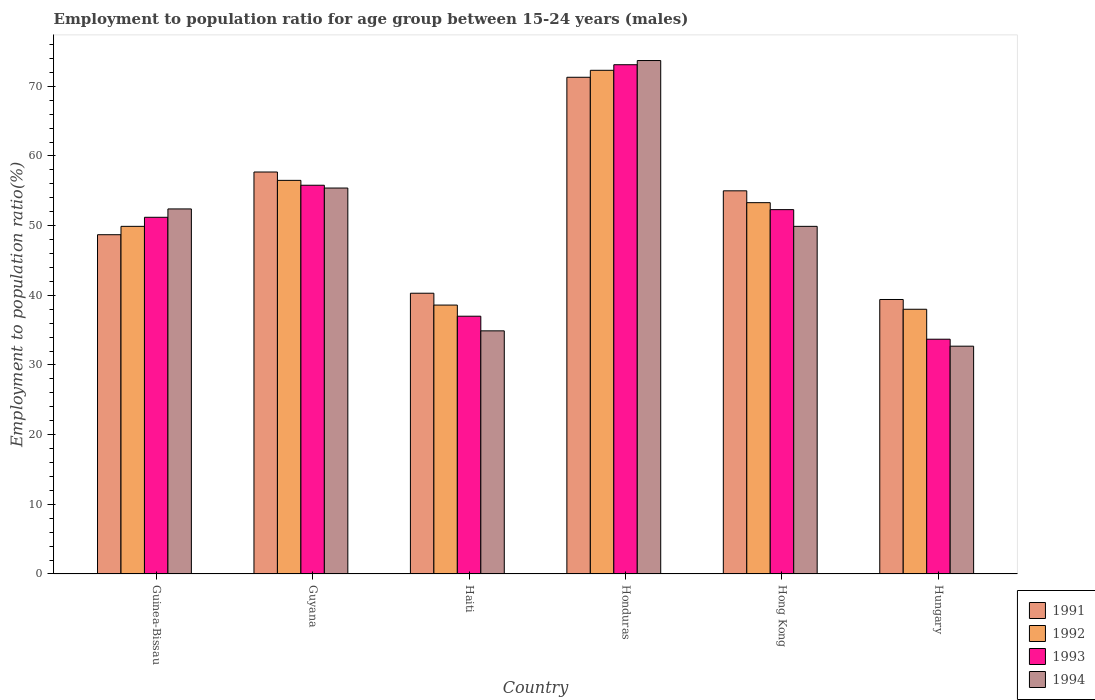What is the label of the 3rd group of bars from the left?
Your answer should be compact. Haiti. What is the employment to population ratio in 1992 in Honduras?
Provide a short and direct response. 72.3. Across all countries, what is the maximum employment to population ratio in 1991?
Your answer should be very brief. 71.3. Across all countries, what is the minimum employment to population ratio in 1993?
Give a very brief answer. 33.7. In which country was the employment to population ratio in 1991 maximum?
Ensure brevity in your answer.  Honduras. In which country was the employment to population ratio in 1994 minimum?
Your response must be concise. Hungary. What is the total employment to population ratio in 1991 in the graph?
Ensure brevity in your answer.  312.4. What is the difference between the employment to population ratio in 1994 in Hungary and the employment to population ratio in 1991 in Hong Kong?
Your answer should be very brief. -22.3. What is the average employment to population ratio in 1993 per country?
Your answer should be very brief. 50.52. What is the difference between the employment to population ratio of/in 1992 and employment to population ratio of/in 1994 in Hong Kong?
Provide a short and direct response. 3.4. What is the ratio of the employment to population ratio in 1991 in Guinea-Bissau to that in Honduras?
Ensure brevity in your answer.  0.68. Is the difference between the employment to population ratio in 1992 in Guinea-Bissau and Guyana greater than the difference between the employment to population ratio in 1994 in Guinea-Bissau and Guyana?
Ensure brevity in your answer.  No. What is the difference between the highest and the second highest employment to population ratio in 1991?
Provide a short and direct response. 2.7. What is the difference between the highest and the lowest employment to population ratio in 1993?
Ensure brevity in your answer.  39.4. In how many countries, is the employment to population ratio in 1992 greater than the average employment to population ratio in 1992 taken over all countries?
Your answer should be compact. 3. What does the 2nd bar from the left in Haiti represents?
Your answer should be very brief. 1992. How many bars are there?
Provide a succinct answer. 24. How many countries are there in the graph?
Offer a very short reply. 6. What is the difference between two consecutive major ticks on the Y-axis?
Ensure brevity in your answer.  10. Where does the legend appear in the graph?
Your response must be concise. Bottom right. How many legend labels are there?
Offer a very short reply. 4. What is the title of the graph?
Provide a short and direct response. Employment to population ratio for age group between 15-24 years (males). Does "1987" appear as one of the legend labels in the graph?
Offer a terse response. No. What is the label or title of the X-axis?
Give a very brief answer. Country. What is the label or title of the Y-axis?
Your answer should be compact. Employment to population ratio(%). What is the Employment to population ratio(%) in 1991 in Guinea-Bissau?
Keep it short and to the point. 48.7. What is the Employment to population ratio(%) in 1992 in Guinea-Bissau?
Offer a very short reply. 49.9. What is the Employment to population ratio(%) of 1993 in Guinea-Bissau?
Make the answer very short. 51.2. What is the Employment to population ratio(%) in 1994 in Guinea-Bissau?
Provide a short and direct response. 52.4. What is the Employment to population ratio(%) in 1991 in Guyana?
Your answer should be compact. 57.7. What is the Employment to population ratio(%) in 1992 in Guyana?
Your answer should be compact. 56.5. What is the Employment to population ratio(%) of 1993 in Guyana?
Make the answer very short. 55.8. What is the Employment to population ratio(%) in 1994 in Guyana?
Your response must be concise. 55.4. What is the Employment to population ratio(%) in 1991 in Haiti?
Provide a short and direct response. 40.3. What is the Employment to population ratio(%) in 1992 in Haiti?
Provide a succinct answer. 38.6. What is the Employment to population ratio(%) in 1993 in Haiti?
Give a very brief answer. 37. What is the Employment to population ratio(%) in 1994 in Haiti?
Offer a terse response. 34.9. What is the Employment to population ratio(%) of 1991 in Honduras?
Provide a succinct answer. 71.3. What is the Employment to population ratio(%) of 1992 in Honduras?
Offer a terse response. 72.3. What is the Employment to population ratio(%) of 1993 in Honduras?
Your answer should be compact. 73.1. What is the Employment to population ratio(%) of 1994 in Honduras?
Your answer should be compact. 73.7. What is the Employment to population ratio(%) of 1992 in Hong Kong?
Your response must be concise. 53.3. What is the Employment to population ratio(%) in 1993 in Hong Kong?
Offer a terse response. 52.3. What is the Employment to population ratio(%) of 1994 in Hong Kong?
Make the answer very short. 49.9. What is the Employment to population ratio(%) of 1991 in Hungary?
Offer a very short reply. 39.4. What is the Employment to population ratio(%) in 1992 in Hungary?
Offer a terse response. 38. What is the Employment to population ratio(%) of 1993 in Hungary?
Your answer should be very brief. 33.7. What is the Employment to population ratio(%) in 1994 in Hungary?
Ensure brevity in your answer.  32.7. Across all countries, what is the maximum Employment to population ratio(%) of 1991?
Provide a succinct answer. 71.3. Across all countries, what is the maximum Employment to population ratio(%) of 1992?
Your answer should be compact. 72.3. Across all countries, what is the maximum Employment to population ratio(%) in 1993?
Provide a short and direct response. 73.1. Across all countries, what is the maximum Employment to population ratio(%) in 1994?
Ensure brevity in your answer.  73.7. Across all countries, what is the minimum Employment to population ratio(%) in 1991?
Your answer should be very brief. 39.4. Across all countries, what is the minimum Employment to population ratio(%) in 1993?
Offer a terse response. 33.7. Across all countries, what is the minimum Employment to population ratio(%) in 1994?
Give a very brief answer. 32.7. What is the total Employment to population ratio(%) in 1991 in the graph?
Keep it short and to the point. 312.4. What is the total Employment to population ratio(%) of 1992 in the graph?
Ensure brevity in your answer.  308.6. What is the total Employment to population ratio(%) in 1993 in the graph?
Your answer should be compact. 303.1. What is the total Employment to population ratio(%) of 1994 in the graph?
Offer a very short reply. 299. What is the difference between the Employment to population ratio(%) of 1993 in Guinea-Bissau and that in Guyana?
Ensure brevity in your answer.  -4.6. What is the difference between the Employment to population ratio(%) of 1991 in Guinea-Bissau and that in Haiti?
Your response must be concise. 8.4. What is the difference between the Employment to population ratio(%) in 1994 in Guinea-Bissau and that in Haiti?
Your answer should be very brief. 17.5. What is the difference between the Employment to population ratio(%) in 1991 in Guinea-Bissau and that in Honduras?
Give a very brief answer. -22.6. What is the difference between the Employment to population ratio(%) in 1992 in Guinea-Bissau and that in Honduras?
Keep it short and to the point. -22.4. What is the difference between the Employment to population ratio(%) of 1993 in Guinea-Bissau and that in Honduras?
Give a very brief answer. -21.9. What is the difference between the Employment to population ratio(%) in 1994 in Guinea-Bissau and that in Honduras?
Make the answer very short. -21.3. What is the difference between the Employment to population ratio(%) of 1994 in Guinea-Bissau and that in Hong Kong?
Provide a succinct answer. 2.5. What is the difference between the Employment to population ratio(%) of 1991 in Guyana and that in Haiti?
Your answer should be compact. 17.4. What is the difference between the Employment to population ratio(%) in 1994 in Guyana and that in Haiti?
Provide a succinct answer. 20.5. What is the difference between the Employment to population ratio(%) of 1991 in Guyana and that in Honduras?
Ensure brevity in your answer.  -13.6. What is the difference between the Employment to population ratio(%) of 1992 in Guyana and that in Honduras?
Offer a terse response. -15.8. What is the difference between the Employment to population ratio(%) of 1993 in Guyana and that in Honduras?
Your answer should be compact. -17.3. What is the difference between the Employment to population ratio(%) of 1994 in Guyana and that in Honduras?
Your response must be concise. -18.3. What is the difference between the Employment to population ratio(%) of 1991 in Guyana and that in Hong Kong?
Ensure brevity in your answer.  2.7. What is the difference between the Employment to population ratio(%) in 1993 in Guyana and that in Hong Kong?
Offer a terse response. 3.5. What is the difference between the Employment to population ratio(%) in 1991 in Guyana and that in Hungary?
Provide a short and direct response. 18.3. What is the difference between the Employment to population ratio(%) of 1993 in Guyana and that in Hungary?
Your answer should be compact. 22.1. What is the difference between the Employment to population ratio(%) in 1994 in Guyana and that in Hungary?
Offer a terse response. 22.7. What is the difference between the Employment to population ratio(%) in 1991 in Haiti and that in Honduras?
Offer a very short reply. -31. What is the difference between the Employment to population ratio(%) in 1992 in Haiti and that in Honduras?
Keep it short and to the point. -33.7. What is the difference between the Employment to population ratio(%) in 1993 in Haiti and that in Honduras?
Provide a short and direct response. -36.1. What is the difference between the Employment to population ratio(%) of 1994 in Haiti and that in Honduras?
Offer a terse response. -38.8. What is the difference between the Employment to population ratio(%) of 1991 in Haiti and that in Hong Kong?
Offer a very short reply. -14.7. What is the difference between the Employment to population ratio(%) in 1992 in Haiti and that in Hong Kong?
Make the answer very short. -14.7. What is the difference between the Employment to population ratio(%) in 1993 in Haiti and that in Hong Kong?
Provide a short and direct response. -15.3. What is the difference between the Employment to population ratio(%) in 1991 in Haiti and that in Hungary?
Ensure brevity in your answer.  0.9. What is the difference between the Employment to population ratio(%) of 1993 in Haiti and that in Hungary?
Give a very brief answer. 3.3. What is the difference between the Employment to population ratio(%) in 1994 in Haiti and that in Hungary?
Ensure brevity in your answer.  2.2. What is the difference between the Employment to population ratio(%) of 1991 in Honduras and that in Hong Kong?
Your answer should be compact. 16.3. What is the difference between the Employment to population ratio(%) of 1992 in Honduras and that in Hong Kong?
Offer a terse response. 19. What is the difference between the Employment to population ratio(%) of 1993 in Honduras and that in Hong Kong?
Offer a terse response. 20.8. What is the difference between the Employment to population ratio(%) of 1994 in Honduras and that in Hong Kong?
Offer a very short reply. 23.8. What is the difference between the Employment to population ratio(%) in 1991 in Honduras and that in Hungary?
Your response must be concise. 31.9. What is the difference between the Employment to population ratio(%) of 1992 in Honduras and that in Hungary?
Your answer should be compact. 34.3. What is the difference between the Employment to population ratio(%) in 1993 in Honduras and that in Hungary?
Offer a terse response. 39.4. What is the difference between the Employment to population ratio(%) of 1991 in Hong Kong and that in Hungary?
Keep it short and to the point. 15.6. What is the difference between the Employment to population ratio(%) of 1992 in Hong Kong and that in Hungary?
Ensure brevity in your answer.  15.3. What is the difference between the Employment to population ratio(%) of 1991 in Guinea-Bissau and the Employment to population ratio(%) of 1992 in Guyana?
Your answer should be very brief. -7.8. What is the difference between the Employment to population ratio(%) in 1991 in Guinea-Bissau and the Employment to population ratio(%) in 1993 in Guyana?
Your answer should be very brief. -7.1. What is the difference between the Employment to population ratio(%) of 1992 in Guinea-Bissau and the Employment to population ratio(%) of 1993 in Guyana?
Provide a short and direct response. -5.9. What is the difference between the Employment to population ratio(%) of 1992 in Guinea-Bissau and the Employment to population ratio(%) of 1994 in Guyana?
Keep it short and to the point. -5.5. What is the difference between the Employment to population ratio(%) in 1993 in Guinea-Bissau and the Employment to population ratio(%) in 1994 in Guyana?
Offer a very short reply. -4.2. What is the difference between the Employment to population ratio(%) of 1992 in Guinea-Bissau and the Employment to population ratio(%) of 1994 in Haiti?
Provide a short and direct response. 15. What is the difference between the Employment to population ratio(%) of 1991 in Guinea-Bissau and the Employment to population ratio(%) of 1992 in Honduras?
Keep it short and to the point. -23.6. What is the difference between the Employment to population ratio(%) in 1991 in Guinea-Bissau and the Employment to population ratio(%) in 1993 in Honduras?
Offer a terse response. -24.4. What is the difference between the Employment to population ratio(%) in 1992 in Guinea-Bissau and the Employment to population ratio(%) in 1993 in Honduras?
Your answer should be compact. -23.2. What is the difference between the Employment to population ratio(%) in 1992 in Guinea-Bissau and the Employment to population ratio(%) in 1994 in Honduras?
Your answer should be very brief. -23.8. What is the difference between the Employment to population ratio(%) in 1993 in Guinea-Bissau and the Employment to population ratio(%) in 1994 in Honduras?
Your response must be concise. -22.5. What is the difference between the Employment to population ratio(%) in 1991 in Guinea-Bissau and the Employment to population ratio(%) in 1993 in Hong Kong?
Your response must be concise. -3.6. What is the difference between the Employment to population ratio(%) in 1992 in Guinea-Bissau and the Employment to population ratio(%) in 1994 in Hong Kong?
Ensure brevity in your answer.  0. What is the difference between the Employment to population ratio(%) in 1991 in Guinea-Bissau and the Employment to population ratio(%) in 1992 in Hungary?
Ensure brevity in your answer.  10.7. What is the difference between the Employment to population ratio(%) of 1991 in Guinea-Bissau and the Employment to population ratio(%) of 1993 in Hungary?
Give a very brief answer. 15. What is the difference between the Employment to population ratio(%) in 1991 in Guinea-Bissau and the Employment to population ratio(%) in 1994 in Hungary?
Ensure brevity in your answer.  16. What is the difference between the Employment to population ratio(%) in 1992 in Guinea-Bissau and the Employment to population ratio(%) in 1994 in Hungary?
Keep it short and to the point. 17.2. What is the difference between the Employment to population ratio(%) in 1991 in Guyana and the Employment to population ratio(%) in 1992 in Haiti?
Offer a very short reply. 19.1. What is the difference between the Employment to population ratio(%) of 1991 in Guyana and the Employment to population ratio(%) of 1993 in Haiti?
Offer a very short reply. 20.7. What is the difference between the Employment to population ratio(%) of 1991 in Guyana and the Employment to population ratio(%) of 1994 in Haiti?
Provide a succinct answer. 22.8. What is the difference between the Employment to population ratio(%) of 1992 in Guyana and the Employment to population ratio(%) of 1994 in Haiti?
Give a very brief answer. 21.6. What is the difference between the Employment to population ratio(%) of 1993 in Guyana and the Employment to population ratio(%) of 1994 in Haiti?
Offer a terse response. 20.9. What is the difference between the Employment to population ratio(%) in 1991 in Guyana and the Employment to population ratio(%) in 1992 in Honduras?
Your response must be concise. -14.6. What is the difference between the Employment to population ratio(%) in 1991 in Guyana and the Employment to population ratio(%) in 1993 in Honduras?
Offer a very short reply. -15.4. What is the difference between the Employment to population ratio(%) in 1992 in Guyana and the Employment to population ratio(%) in 1993 in Honduras?
Offer a very short reply. -16.6. What is the difference between the Employment to population ratio(%) of 1992 in Guyana and the Employment to population ratio(%) of 1994 in Honduras?
Ensure brevity in your answer.  -17.2. What is the difference between the Employment to population ratio(%) of 1993 in Guyana and the Employment to population ratio(%) of 1994 in Honduras?
Offer a terse response. -17.9. What is the difference between the Employment to population ratio(%) of 1991 in Guyana and the Employment to population ratio(%) of 1992 in Hong Kong?
Provide a succinct answer. 4.4. What is the difference between the Employment to population ratio(%) in 1992 in Guyana and the Employment to population ratio(%) in 1994 in Hong Kong?
Your answer should be compact. 6.6. What is the difference between the Employment to population ratio(%) of 1993 in Guyana and the Employment to population ratio(%) of 1994 in Hong Kong?
Make the answer very short. 5.9. What is the difference between the Employment to population ratio(%) of 1991 in Guyana and the Employment to population ratio(%) of 1993 in Hungary?
Your answer should be compact. 24. What is the difference between the Employment to population ratio(%) of 1992 in Guyana and the Employment to population ratio(%) of 1993 in Hungary?
Your response must be concise. 22.8. What is the difference between the Employment to population ratio(%) of 1992 in Guyana and the Employment to population ratio(%) of 1994 in Hungary?
Make the answer very short. 23.8. What is the difference between the Employment to population ratio(%) of 1993 in Guyana and the Employment to population ratio(%) of 1994 in Hungary?
Make the answer very short. 23.1. What is the difference between the Employment to population ratio(%) of 1991 in Haiti and the Employment to population ratio(%) of 1992 in Honduras?
Offer a terse response. -32. What is the difference between the Employment to population ratio(%) of 1991 in Haiti and the Employment to population ratio(%) of 1993 in Honduras?
Provide a succinct answer. -32.8. What is the difference between the Employment to population ratio(%) of 1991 in Haiti and the Employment to population ratio(%) of 1994 in Honduras?
Offer a terse response. -33.4. What is the difference between the Employment to population ratio(%) in 1992 in Haiti and the Employment to population ratio(%) in 1993 in Honduras?
Your answer should be very brief. -34.5. What is the difference between the Employment to population ratio(%) in 1992 in Haiti and the Employment to population ratio(%) in 1994 in Honduras?
Your answer should be compact. -35.1. What is the difference between the Employment to population ratio(%) of 1993 in Haiti and the Employment to population ratio(%) of 1994 in Honduras?
Offer a terse response. -36.7. What is the difference between the Employment to population ratio(%) of 1992 in Haiti and the Employment to population ratio(%) of 1993 in Hong Kong?
Provide a succinct answer. -13.7. What is the difference between the Employment to population ratio(%) of 1991 in Haiti and the Employment to population ratio(%) of 1993 in Hungary?
Your answer should be compact. 6.6. What is the difference between the Employment to population ratio(%) of 1991 in Haiti and the Employment to population ratio(%) of 1994 in Hungary?
Offer a very short reply. 7.6. What is the difference between the Employment to population ratio(%) of 1993 in Haiti and the Employment to population ratio(%) of 1994 in Hungary?
Offer a terse response. 4.3. What is the difference between the Employment to population ratio(%) in 1991 in Honduras and the Employment to population ratio(%) in 1993 in Hong Kong?
Your answer should be very brief. 19. What is the difference between the Employment to population ratio(%) of 1991 in Honduras and the Employment to population ratio(%) of 1994 in Hong Kong?
Offer a very short reply. 21.4. What is the difference between the Employment to population ratio(%) of 1992 in Honduras and the Employment to population ratio(%) of 1993 in Hong Kong?
Offer a terse response. 20. What is the difference between the Employment to population ratio(%) in 1992 in Honduras and the Employment to population ratio(%) in 1994 in Hong Kong?
Offer a terse response. 22.4. What is the difference between the Employment to population ratio(%) in 1993 in Honduras and the Employment to population ratio(%) in 1994 in Hong Kong?
Offer a very short reply. 23.2. What is the difference between the Employment to population ratio(%) in 1991 in Honduras and the Employment to population ratio(%) in 1992 in Hungary?
Keep it short and to the point. 33.3. What is the difference between the Employment to population ratio(%) in 1991 in Honduras and the Employment to population ratio(%) in 1993 in Hungary?
Ensure brevity in your answer.  37.6. What is the difference between the Employment to population ratio(%) of 1991 in Honduras and the Employment to population ratio(%) of 1994 in Hungary?
Ensure brevity in your answer.  38.6. What is the difference between the Employment to population ratio(%) of 1992 in Honduras and the Employment to population ratio(%) of 1993 in Hungary?
Offer a terse response. 38.6. What is the difference between the Employment to population ratio(%) in 1992 in Honduras and the Employment to population ratio(%) in 1994 in Hungary?
Your answer should be very brief. 39.6. What is the difference between the Employment to population ratio(%) of 1993 in Honduras and the Employment to population ratio(%) of 1994 in Hungary?
Make the answer very short. 40.4. What is the difference between the Employment to population ratio(%) of 1991 in Hong Kong and the Employment to population ratio(%) of 1992 in Hungary?
Ensure brevity in your answer.  17. What is the difference between the Employment to population ratio(%) in 1991 in Hong Kong and the Employment to population ratio(%) in 1993 in Hungary?
Keep it short and to the point. 21.3. What is the difference between the Employment to population ratio(%) in 1991 in Hong Kong and the Employment to population ratio(%) in 1994 in Hungary?
Offer a very short reply. 22.3. What is the difference between the Employment to population ratio(%) in 1992 in Hong Kong and the Employment to population ratio(%) in 1993 in Hungary?
Provide a succinct answer. 19.6. What is the difference between the Employment to population ratio(%) of 1992 in Hong Kong and the Employment to population ratio(%) of 1994 in Hungary?
Keep it short and to the point. 20.6. What is the difference between the Employment to population ratio(%) in 1993 in Hong Kong and the Employment to population ratio(%) in 1994 in Hungary?
Give a very brief answer. 19.6. What is the average Employment to population ratio(%) of 1991 per country?
Ensure brevity in your answer.  52.07. What is the average Employment to population ratio(%) of 1992 per country?
Keep it short and to the point. 51.43. What is the average Employment to population ratio(%) of 1993 per country?
Ensure brevity in your answer.  50.52. What is the average Employment to population ratio(%) of 1994 per country?
Your response must be concise. 49.83. What is the difference between the Employment to population ratio(%) in 1991 and Employment to population ratio(%) in 1993 in Guinea-Bissau?
Offer a very short reply. -2.5. What is the difference between the Employment to population ratio(%) of 1991 and Employment to population ratio(%) of 1994 in Guinea-Bissau?
Your response must be concise. -3.7. What is the difference between the Employment to population ratio(%) in 1993 and Employment to population ratio(%) in 1994 in Guinea-Bissau?
Ensure brevity in your answer.  -1.2. What is the difference between the Employment to population ratio(%) of 1991 and Employment to population ratio(%) of 1993 in Guyana?
Your answer should be very brief. 1.9. What is the difference between the Employment to population ratio(%) of 1991 and Employment to population ratio(%) of 1994 in Guyana?
Your answer should be very brief. 2.3. What is the difference between the Employment to population ratio(%) in 1991 and Employment to population ratio(%) in 1992 in Haiti?
Make the answer very short. 1.7. What is the difference between the Employment to population ratio(%) of 1991 and Employment to population ratio(%) of 1994 in Haiti?
Offer a terse response. 5.4. What is the difference between the Employment to population ratio(%) of 1992 and Employment to population ratio(%) of 1994 in Haiti?
Provide a succinct answer. 3.7. What is the difference between the Employment to population ratio(%) of 1993 and Employment to population ratio(%) of 1994 in Haiti?
Make the answer very short. 2.1. What is the difference between the Employment to population ratio(%) of 1991 and Employment to population ratio(%) of 1992 in Honduras?
Offer a very short reply. -1. What is the difference between the Employment to population ratio(%) of 1991 and Employment to population ratio(%) of 1993 in Honduras?
Your answer should be very brief. -1.8. What is the difference between the Employment to population ratio(%) in 1992 and Employment to population ratio(%) in 1993 in Honduras?
Offer a terse response. -0.8. What is the difference between the Employment to population ratio(%) of 1992 and Employment to population ratio(%) of 1994 in Honduras?
Your response must be concise. -1.4. What is the difference between the Employment to population ratio(%) of 1991 and Employment to population ratio(%) of 1992 in Hong Kong?
Your answer should be compact. 1.7. What is the difference between the Employment to population ratio(%) of 1992 and Employment to population ratio(%) of 1993 in Hong Kong?
Provide a succinct answer. 1. What is the difference between the Employment to population ratio(%) of 1992 and Employment to population ratio(%) of 1994 in Hong Kong?
Provide a short and direct response. 3.4. What is the difference between the Employment to population ratio(%) of 1991 and Employment to population ratio(%) of 1993 in Hungary?
Offer a very short reply. 5.7. What is the difference between the Employment to population ratio(%) of 1991 and Employment to population ratio(%) of 1994 in Hungary?
Your answer should be compact. 6.7. What is the difference between the Employment to population ratio(%) of 1992 and Employment to population ratio(%) of 1993 in Hungary?
Your response must be concise. 4.3. What is the difference between the Employment to population ratio(%) in 1993 and Employment to population ratio(%) in 1994 in Hungary?
Keep it short and to the point. 1. What is the ratio of the Employment to population ratio(%) of 1991 in Guinea-Bissau to that in Guyana?
Keep it short and to the point. 0.84. What is the ratio of the Employment to population ratio(%) of 1992 in Guinea-Bissau to that in Guyana?
Ensure brevity in your answer.  0.88. What is the ratio of the Employment to population ratio(%) of 1993 in Guinea-Bissau to that in Guyana?
Make the answer very short. 0.92. What is the ratio of the Employment to population ratio(%) in 1994 in Guinea-Bissau to that in Guyana?
Make the answer very short. 0.95. What is the ratio of the Employment to population ratio(%) of 1991 in Guinea-Bissau to that in Haiti?
Your response must be concise. 1.21. What is the ratio of the Employment to population ratio(%) of 1992 in Guinea-Bissau to that in Haiti?
Your answer should be very brief. 1.29. What is the ratio of the Employment to population ratio(%) of 1993 in Guinea-Bissau to that in Haiti?
Offer a terse response. 1.38. What is the ratio of the Employment to population ratio(%) in 1994 in Guinea-Bissau to that in Haiti?
Provide a succinct answer. 1.5. What is the ratio of the Employment to population ratio(%) of 1991 in Guinea-Bissau to that in Honduras?
Provide a succinct answer. 0.68. What is the ratio of the Employment to population ratio(%) of 1992 in Guinea-Bissau to that in Honduras?
Keep it short and to the point. 0.69. What is the ratio of the Employment to population ratio(%) of 1993 in Guinea-Bissau to that in Honduras?
Make the answer very short. 0.7. What is the ratio of the Employment to population ratio(%) of 1994 in Guinea-Bissau to that in Honduras?
Give a very brief answer. 0.71. What is the ratio of the Employment to population ratio(%) in 1991 in Guinea-Bissau to that in Hong Kong?
Your response must be concise. 0.89. What is the ratio of the Employment to population ratio(%) in 1992 in Guinea-Bissau to that in Hong Kong?
Keep it short and to the point. 0.94. What is the ratio of the Employment to population ratio(%) in 1993 in Guinea-Bissau to that in Hong Kong?
Ensure brevity in your answer.  0.98. What is the ratio of the Employment to population ratio(%) of 1994 in Guinea-Bissau to that in Hong Kong?
Keep it short and to the point. 1.05. What is the ratio of the Employment to population ratio(%) of 1991 in Guinea-Bissau to that in Hungary?
Give a very brief answer. 1.24. What is the ratio of the Employment to population ratio(%) of 1992 in Guinea-Bissau to that in Hungary?
Provide a short and direct response. 1.31. What is the ratio of the Employment to population ratio(%) in 1993 in Guinea-Bissau to that in Hungary?
Offer a terse response. 1.52. What is the ratio of the Employment to population ratio(%) in 1994 in Guinea-Bissau to that in Hungary?
Offer a terse response. 1.6. What is the ratio of the Employment to population ratio(%) of 1991 in Guyana to that in Haiti?
Your answer should be compact. 1.43. What is the ratio of the Employment to population ratio(%) in 1992 in Guyana to that in Haiti?
Offer a terse response. 1.46. What is the ratio of the Employment to population ratio(%) in 1993 in Guyana to that in Haiti?
Give a very brief answer. 1.51. What is the ratio of the Employment to population ratio(%) in 1994 in Guyana to that in Haiti?
Your response must be concise. 1.59. What is the ratio of the Employment to population ratio(%) in 1991 in Guyana to that in Honduras?
Provide a succinct answer. 0.81. What is the ratio of the Employment to population ratio(%) in 1992 in Guyana to that in Honduras?
Provide a short and direct response. 0.78. What is the ratio of the Employment to population ratio(%) in 1993 in Guyana to that in Honduras?
Offer a terse response. 0.76. What is the ratio of the Employment to population ratio(%) in 1994 in Guyana to that in Honduras?
Your answer should be compact. 0.75. What is the ratio of the Employment to population ratio(%) of 1991 in Guyana to that in Hong Kong?
Ensure brevity in your answer.  1.05. What is the ratio of the Employment to population ratio(%) in 1992 in Guyana to that in Hong Kong?
Give a very brief answer. 1.06. What is the ratio of the Employment to population ratio(%) of 1993 in Guyana to that in Hong Kong?
Offer a terse response. 1.07. What is the ratio of the Employment to population ratio(%) in 1994 in Guyana to that in Hong Kong?
Provide a succinct answer. 1.11. What is the ratio of the Employment to population ratio(%) of 1991 in Guyana to that in Hungary?
Your answer should be compact. 1.46. What is the ratio of the Employment to population ratio(%) in 1992 in Guyana to that in Hungary?
Your answer should be compact. 1.49. What is the ratio of the Employment to population ratio(%) in 1993 in Guyana to that in Hungary?
Make the answer very short. 1.66. What is the ratio of the Employment to population ratio(%) in 1994 in Guyana to that in Hungary?
Provide a succinct answer. 1.69. What is the ratio of the Employment to population ratio(%) of 1991 in Haiti to that in Honduras?
Your response must be concise. 0.57. What is the ratio of the Employment to population ratio(%) in 1992 in Haiti to that in Honduras?
Your response must be concise. 0.53. What is the ratio of the Employment to population ratio(%) in 1993 in Haiti to that in Honduras?
Your answer should be compact. 0.51. What is the ratio of the Employment to population ratio(%) of 1994 in Haiti to that in Honduras?
Your response must be concise. 0.47. What is the ratio of the Employment to population ratio(%) of 1991 in Haiti to that in Hong Kong?
Provide a succinct answer. 0.73. What is the ratio of the Employment to population ratio(%) of 1992 in Haiti to that in Hong Kong?
Offer a very short reply. 0.72. What is the ratio of the Employment to population ratio(%) in 1993 in Haiti to that in Hong Kong?
Offer a terse response. 0.71. What is the ratio of the Employment to population ratio(%) in 1994 in Haiti to that in Hong Kong?
Your answer should be very brief. 0.7. What is the ratio of the Employment to population ratio(%) in 1991 in Haiti to that in Hungary?
Provide a short and direct response. 1.02. What is the ratio of the Employment to population ratio(%) of 1992 in Haiti to that in Hungary?
Keep it short and to the point. 1.02. What is the ratio of the Employment to population ratio(%) in 1993 in Haiti to that in Hungary?
Your response must be concise. 1.1. What is the ratio of the Employment to population ratio(%) of 1994 in Haiti to that in Hungary?
Provide a succinct answer. 1.07. What is the ratio of the Employment to population ratio(%) in 1991 in Honduras to that in Hong Kong?
Ensure brevity in your answer.  1.3. What is the ratio of the Employment to population ratio(%) in 1992 in Honduras to that in Hong Kong?
Make the answer very short. 1.36. What is the ratio of the Employment to population ratio(%) of 1993 in Honduras to that in Hong Kong?
Give a very brief answer. 1.4. What is the ratio of the Employment to population ratio(%) in 1994 in Honduras to that in Hong Kong?
Your answer should be compact. 1.48. What is the ratio of the Employment to population ratio(%) in 1991 in Honduras to that in Hungary?
Give a very brief answer. 1.81. What is the ratio of the Employment to population ratio(%) of 1992 in Honduras to that in Hungary?
Your answer should be compact. 1.9. What is the ratio of the Employment to population ratio(%) in 1993 in Honduras to that in Hungary?
Your answer should be compact. 2.17. What is the ratio of the Employment to population ratio(%) of 1994 in Honduras to that in Hungary?
Your answer should be compact. 2.25. What is the ratio of the Employment to population ratio(%) of 1991 in Hong Kong to that in Hungary?
Ensure brevity in your answer.  1.4. What is the ratio of the Employment to population ratio(%) in 1992 in Hong Kong to that in Hungary?
Make the answer very short. 1.4. What is the ratio of the Employment to population ratio(%) in 1993 in Hong Kong to that in Hungary?
Keep it short and to the point. 1.55. What is the ratio of the Employment to population ratio(%) in 1994 in Hong Kong to that in Hungary?
Provide a short and direct response. 1.53. What is the difference between the highest and the second highest Employment to population ratio(%) of 1993?
Provide a short and direct response. 17.3. What is the difference between the highest and the lowest Employment to population ratio(%) in 1991?
Provide a succinct answer. 31.9. What is the difference between the highest and the lowest Employment to population ratio(%) of 1992?
Provide a short and direct response. 34.3. What is the difference between the highest and the lowest Employment to population ratio(%) of 1993?
Offer a terse response. 39.4. 